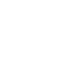Convert code to text. <code><loc_0><loc_0><loc_500><loc_500><_SQL_>
</code> 